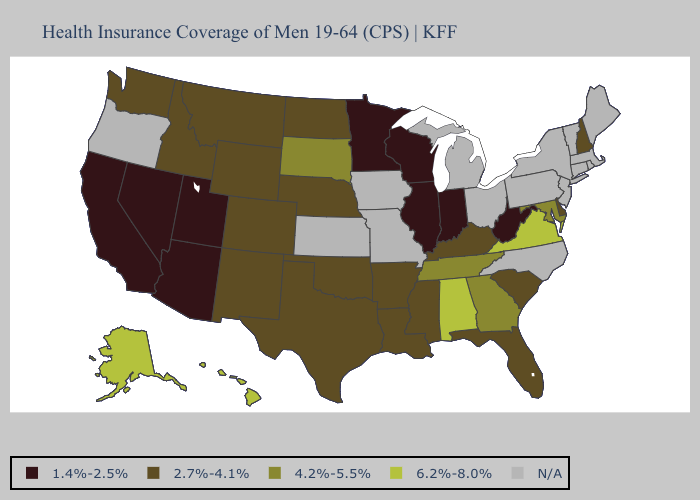What is the value of Alaska?
Be succinct. 6.2%-8.0%. Name the states that have a value in the range 4.2%-5.5%?
Answer briefly. Georgia, Maryland, South Dakota, Tennessee. What is the lowest value in the USA?
Write a very short answer. 1.4%-2.5%. Name the states that have a value in the range N/A?
Concise answer only. Connecticut, Iowa, Kansas, Maine, Massachusetts, Michigan, Missouri, New Jersey, New York, North Carolina, Ohio, Oregon, Pennsylvania, Rhode Island, Vermont. Which states hav the highest value in the West?
Keep it brief. Alaska, Hawaii. What is the value of Missouri?
Give a very brief answer. N/A. Does Minnesota have the lowest value in the MidWest?
Answer briefly. Yes. Is the legend a continuous bar?
Be succinct. No. What is the value of Ohio?
Quick response, please. N/A. What is the highest value in states that border Idaho?
Concise answer only. 2.7%-4.1%. What is the value of North Dakota?
Answer briefly. 2.7%-4.1%. 